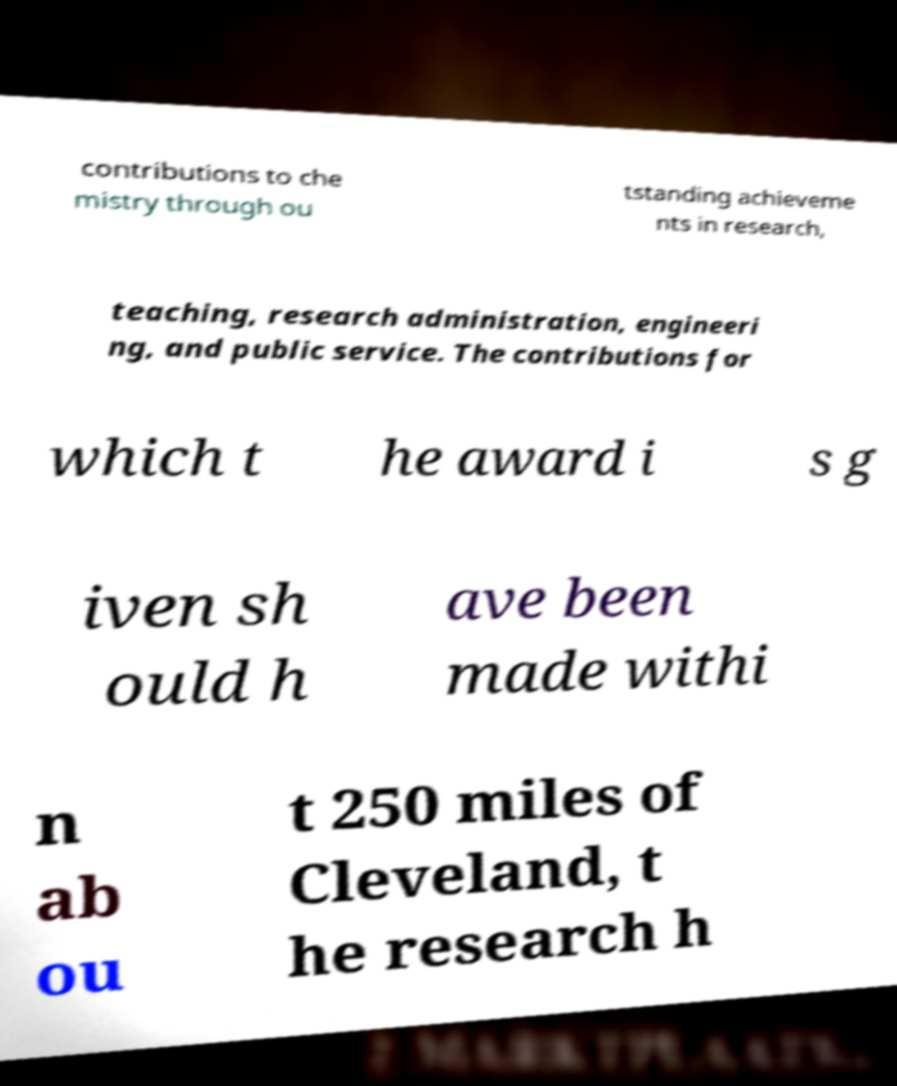Please identify and transcribe the text found in this image. contributions to che mistry through ou tstanding achieveme nts in research, teaching, research administration, engineeri ng, and public service. The contributions for which t he award i s g iven sh ould h ave been made withi n ab ou t 250 miles of Cleveland, t he research h 